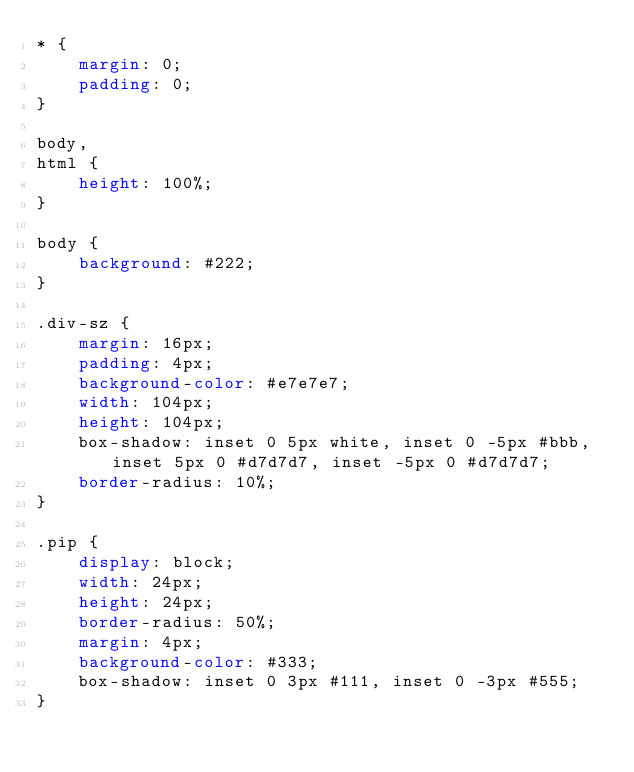<code> <loc_0><loc_0><loc_500><loc_500><_CSS_>* {
    margin: 0;
    padding: 0;
}

body,
html {
    height: 100%;
}

body {
    background: #222;
}

.div-sz {
    margin: 16px;
    padding: 4px;
    background-color: #e7e7e7;
    width: 104px;
    height: 104px;
    box-shadow: inset 0 5px white, inset 0 -5px #bbb, inset 5px 0 #d7d7d7, inset -5px 0 #d7d7d7;
    border-radius: 10%;
}

.pip {
    display: block;
    width: 24px;
    height: 24px;
    border-radius: 50%;
    margin: 4px;
    background-color: #333;
    box-shadow: inset 0 3px #111, inset 0 -3px #555;
}
</code> 